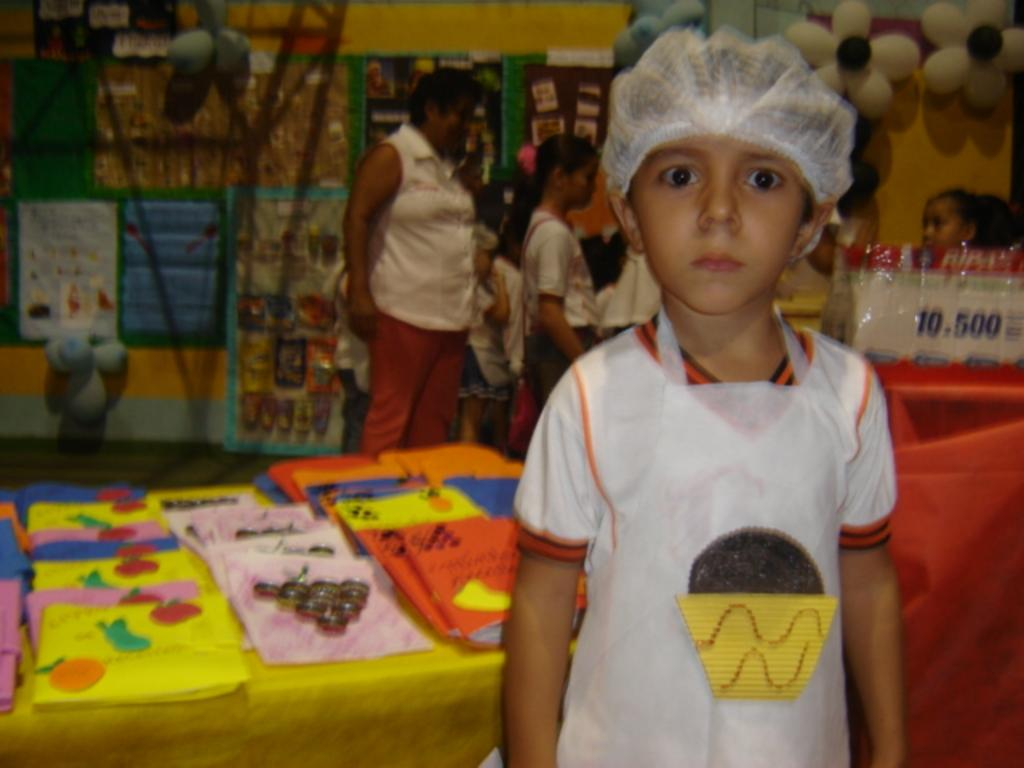What objects can be seen in the foreground of the picture? There are books, a table, a card, and a kid in the foreground of the picture. What is the kid doing in the foreground of the picture? The kid is present in the foreground of the picture, but their specific actions are not clear from the provided facts. What can be seen in the background of the picture? There are people, posters, balloons, a wall, and other things in the background of the picture. What type of fear can be seen on the kid's face in the picture? There is no indication of fear on the kid's face in the picture, as their facial expression is not described in the provided facts. What kind of beast is present in the background of the picture? There is no mention of a beast in the background of the picture; the provided facts only mention people, posters, balloons, a wall, and other things. 